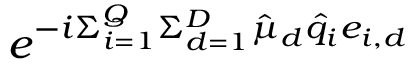Convert formula to latex. <formula><loc_0><loc_0><loc_500><loc_500>e ^ { - i \Sigma _ { i = 1 } ^ { Q } \Sigma _ { d = 1 } ^ { D } \hat { \mu } _ { d } \hat { q } _ { i } e _ { i , d } }</formula> 